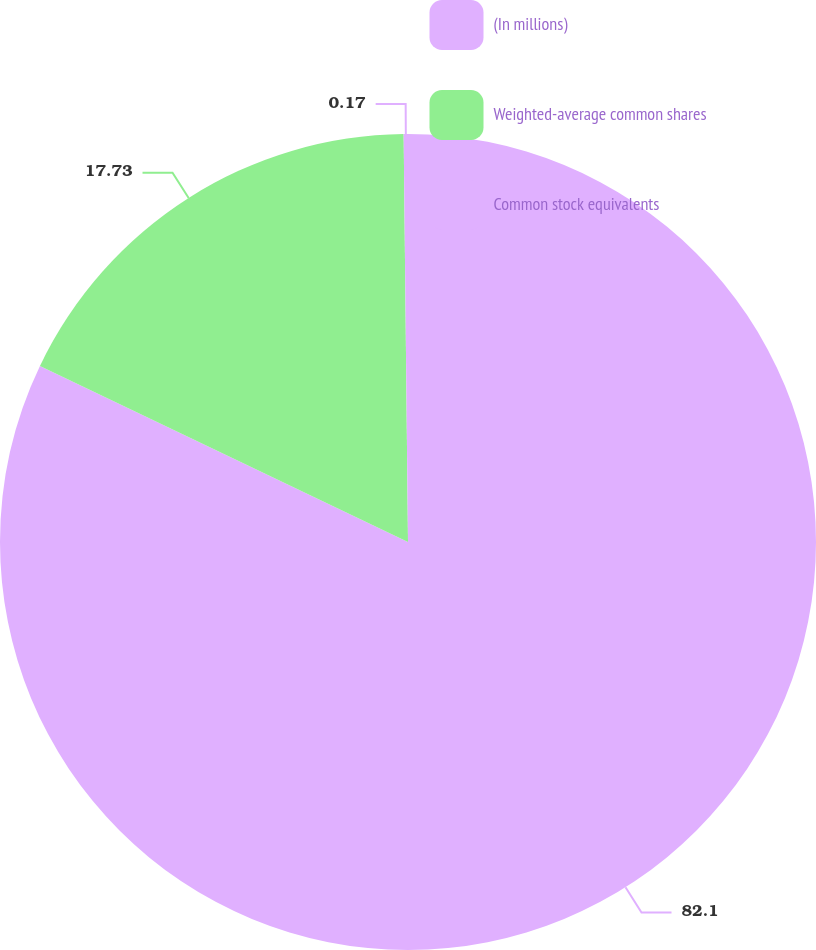Convert chart. <chart><loc_0><loc_0><loc_500><loc_500><pie_chart><fcel>(In millions)<fcel>Weighted-average common shares<fcel>Common stock equivalents<nl><fcel>82.11%<fcel>17.73%<fcel>0.17%<nl></chart> 